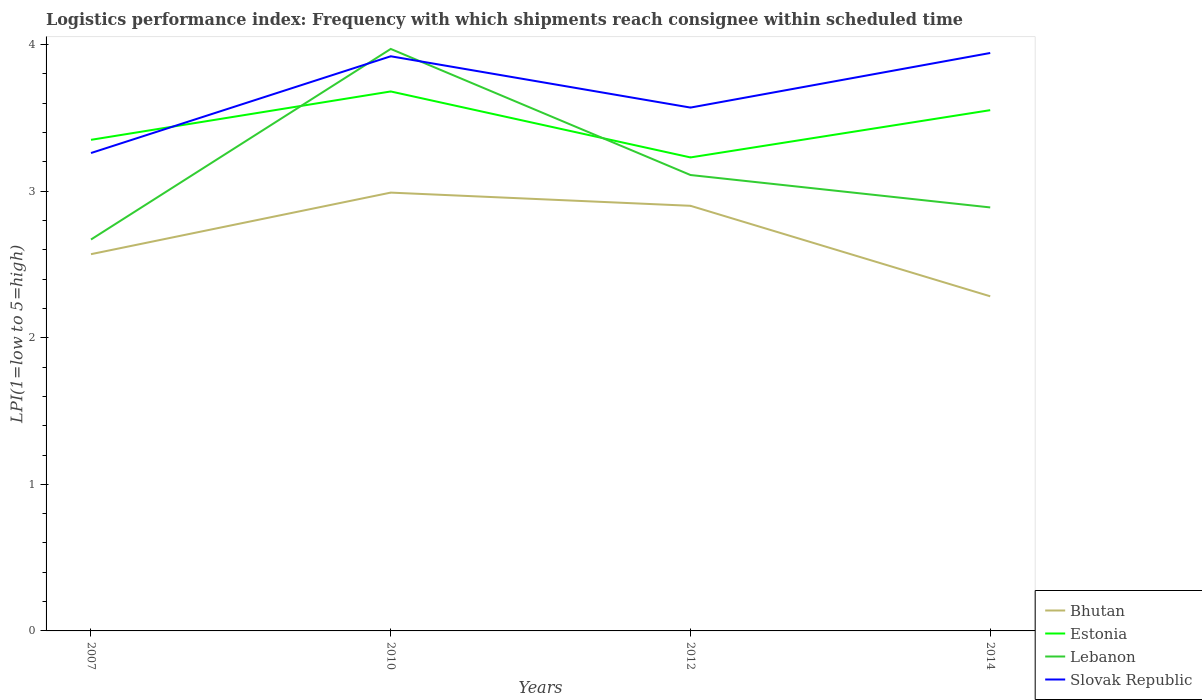Is the number of lines equal to the number of legend labels?
Your answer should be compact. Yes. Across all years, what is the maximum logistics performance index in Bhutan?
Offer a very short reply. 2.28. In which year was the logistics performance index in Bhutan maximum?
Your response must be concise. 2014. What is the total logistics performance index in Slovak Republic in the graph?
Keep it short and to the point. -0.66. What is the difference between the highest and the second highest logistics performance index in Lebanon?
Provide a succinct answer. 1.3. What is the difference between the highest and the lowest logistics performance index in Slovak Republic?
Provide a succinct answer. 2. Is the logistics performance index in Slovak Republic strictly greater than the logistics performance index in Estonia over the years?
Offer a terse response. No. What is the difference between two consecutive major ticks on the Y-axis?
Your response must be concise. 1. Does the graph contain any zero values?
Keep it short and to the point. No. Where does the legend appear in the graph?
Offer a terse response. Bottom right. How many legend labels are there?
Your response must be concise. 4. How are the legend labels stacked?
Provide a succinct answer. Vertical. What is the title of the graph?
Keep it short and to the point. Logistics performance index: Frequency with which shipments reach consignee within scheduled time. Does "Malawi" appear as one of the legend labels in the graph?
Your response must be concise. No. What is the label or title of the Y-axis?
Provide a succinct answer. LPI(1=low to 5=high). What is the LPI(1=low to 5=high) of Bhutan in 2007?
Give a very brief answer. 2.57. What is the LPI(1=low to 5=high) in Estonia in 2007?
Make the answer very short. 3.35. What is the LPI(1=low to 5=high) in Lebanon in 2007?
Provide a succinct answer. 2.67. What is the LPI(1=low to 5=high) in Slovak Republic in 2007?
Ensure brevity in your answer.  3.26. What is the LPI(1=low to 5=high) of Bhutan in 2010?
Ensure brevity in your answer.  2.99. What is the LPI(1=low to 5=high) in Estonia in 2010?
Your response must be concise. 3.68. What is the LPI(1=low to 5=high) of Lebanon in 2010?
Ensure brevity in your answer.  3.97. What is the LPI(1=low to 5=high) of Slovak Republic in 2010?
Ensure brevity in your answer.  3.92. What is the LPI(1=low to 5=high) of Bhutan in 2012?
Offer a very short reply. 2.9. What is the LPI(1=low to 5=high) in Estonia in 2012?
Give a very brief answer. 3.23. What is the LPI(1=low to 5=high) of Lebanon in 2012?
Ensure brevity in your answer.  3.11. What is the LPI(1=low to 5=high) of Slovak Republic in 2012?
Ensure brevity in your answer.  3.57. What is the LPI(1=low to 5=high) in Bhutan in 2014?
Provide a short and direct response. 2.28. What is the LPI(1=low to 5=high) in Estonia in 2014?
Offer a very short reply. 3.55. What is the LPI(1=low to 5=high) in Lebanon in 2014?
Make the answer very short. 2.89. What is the LPI(1=low to 5=high) in Slovak Republic in 2014?
Offer a very short reply. 3.94. Across all years, what is the maximum LPI(1=low to 5=high) in Bhutan?
Provide a short and direct response. 2.99. Across all years, what is the maximum LPI(1=low to 5=high) of Estonia?
Keep it short and to the point. 3.68. Across all years, what is the maximum LPI(1=low to 5=high) in Lebanon?
Your response must be concise. 3.97. Across all years, what is the maximum LPI(1=low to 5=high) in Slovak Republic?
Your answer should be very brief. 3.94. Across all years, what is the minimum LPI(1=low to 5=high) in Bhutan?
Your answer should be very brief. 2.28. Across all years, what is the minimum LPI(1=low to 5=high) of Estonia?
Provide a short and direct response. 3.23. Across all years, what is the minimum LPI(1=low to 5=high) in Lebanon?
Keep it short and to the point. 2.67. Across all years, what is the minimum LPI(1=low to 5=high) of Slovak Republic?
Give a very brief answer. 3.26. What is the total LPI(1=low to 5=high) in Bhutan in the graph?
Your answer should be compact. 10.74. What is the total LPI(1=low to 5=high) of Estonia in the graph?
Offer a terse response. 13.81. What is the total LPI(1=low to 5=high) in Lebanon in the graph?
Your answer should be compact. 12.64. What is the total LPI(1=low to 5=high) in Slovak Republic in the graph?
Your response must be concise. 14.69. What is the difference between the LPI(1=low to 5=high) in Bhutan in 2007 and that in 2010?
Give a very brief answer. -0.42. What is the difference between the LPI(1=low to 5=high) of Estonia in 2007 and that in 2010?
Ensure brevity in your answer.  -0.33. What is the difference between the LPI(1=low to 5=high) of Slovak Republic in 2007 and that in 2010?
Make the answer very short. -0.66. What is the difference between the LPI(1=low to 5=high) of Bhutan in 2007 and that in 2012?
Your answer should be very brief. -0.33. What is the difference between the LPI(1=low to 5=high) of Estonia in 2007 and that in 2012?
Offer a very short reply. 0.12. What is the difference between the LPI(1=low to 5=high) of Lebanon in 2007 and that in 2012?
Make the answer very short. -0.44. What is the difference between the LPI(1=low to 5=high) of Slovak Republic in 2007 and that in 2012?
Offer a very short reply. -0.31. What is the difference between the LPI(1=low to 5=high) in Bhutan in 2007 and that in 2014?
Make the answer very short. 0.29. What is the difference between the LPI(1=low to 5=high) in Estonia in 2007 and that in 2014?
Ensure brevity in your answer.  -0.2. What is the difference between the LPI(1=low to 5=high) of Lebanon in 2007 and that in 2014?
Offer a terse response. -0.22. What is the difference between the LPI(1=low to 5=high) in Slovak Republic in 2007 and that in 2014?
Offer a terse response. -0.68. What is the difference between the LPI(1=low to 5=high) of Bhutan in 2010 and that in 2012?
Give a very brief answer. 0.09. What is the difference between the LPI(1=low to 5=high) of Estonia in 2010 and that in 2012?
Your answer should be very brief. 0.45. What is the difference between the LPI(1=low to 5=high) in Lebanon in 2010 and that in 2012?
Provide a succinct answer. 0.86. What is the difference between the LPI(1=low to 5=high) of Slovak Republic in 2010 and that in 2012?
Offer a terse response. 0.35. What is the difference between the LPI(1=low to 5=high) in Bhutan in 2010 and that in 2014?
Provide a succinct answer. 0.71. What is the difference between the LPI(1=low to 5=high) of Estonia in 2010 and that in 2014?
Keep it short and to the point. 0.13. What is the difference between the LPI(1=low to 5=high) of Lebanon in 2010 and that in 2014?
Offer a very short reply. 1.08. What is the difference between the LPI(1=low to 5=high) of Slovak Republic in 2010 and that in 2014?
Make the answer very short. -0.02. What is the difference between the LPI(1=low to 5=high) in Bhutan in 2012 and that in 2014?
Offer a terse response. 0.62. What is the difference between the LPI(1=low to 5=high) in Estonia in 2012 and that in 2014?
Offer a very short reply. -0.32. What is the difference between the LPI(1=low to 5=high) in Lebanon in 2012 and that in 2014?
Keep it short and to the point. 0.22. What is the difference between the LPI(1=low to 5=high) in Slovak Republic in 2012 and that in 2014?
Your answer should be very brief. -0.37. What is the difference between the LPI(1=low to 5=high) in Bhutan in 2007 and the LPI(1=low to 5=high) in Estonia in 2010?
Make the answer very short. -1.11. What is the difference between the LPI(1=low to 5=high) in Bhutan in 2007 and the LPI(1=low to 5=high) in Slovak Republic in 2010?
Provide a succinct answer. -1.35. What is the difference between the LPI(1=low to 5=high) of Estonia in 2007 and the LPI(1=low to 5=high) of Lebanon in 2010?
Offer a very short reply. -0.62. What is the difference between the LPI(1=low to 5=high) of Estonia in 2007 and the LPI(1=low to 5=high) of Slovak Republic in 2010?
Your answer should be compact. -0.57. What is the difference between the LPI(1=low to 5=high) in Lebanon in 2007 and the LPI(1=low to 5=high) in Slovak Republic in 2010?
Offer a terse response. -1.25. What is the difference between the LPI(1=low to 5=high) of Bhutan in 2007 and the LPI(1=low to 5=high) of Estonia in 2012?
Provide a succinct answer. -0.66. What is the difference between the LPI(1=low to 5=high) of Bhutan in 2007 and the LPI(1=low to 5=high) of Lebanon in 2012?
Your answer should be very brief. -0.54. What is the difference between the LPI(1=low to 5=high) of Estonia in 2007 and the LPI(1=low to 5=high) of Lebanon in 2012?
Make the answer very short. 0.24. What is the difference between the LPI(1=low to 5=high) of Estonia in 2007 and the LPI(1=low to 5=high) of Slovak Republic in 2012?
Provide a succinct answer. -0.22. What is the difference between the LPI(1=low to 5=high) of Lebanon in 2007 and the LPI(1=low to 5=high) of Slovak Republic in 2012?
Offer a terse response. -0.9. What is the difference between the LPI(1=low to 5=high) of Bhutan in 2007 and the LPI(1=low to 5=high) of Estonia in 2014?
Provide a succinct answer. -0.98. What is the difference between the LPI(1=low to 5=high) of Bhutan in 2007 and the LPI(1=low to 5=high) of Lebanon in 2014?
Keep it short and to the point. -0.32. What is the difference between the LPI(1=low to 5=high) in Bhutan in 2007 and the LPI(1=low to 5=high) in Slovak Republic in 2014?
Offer a terse response. -1.37. What is the difference between the LPI(1=low to 5=high) in Estonia in 2007 and the LPI(1=low to 5=high) in Lebanon in 2014?
Offer a terse response. 0.46. What is the difference between the LPI(1=low to 5=high) in Estonia in 2007 and the LPI(1=low to 5=high) in Slovak Republic in 2014?
Your answer should be compact. -0.59. What is the difference between the LPI(1=low to 5=high) in Lebanon in 2007 and the LPI(1=low to 5=high) in Slovak Republic in 2014?
Provide a succinct answer. -1.27. What is the difference between the LPI(1=low to 5=high) in Bhutan in 2010 and the LPI(1=low to 5=high) in Estonia in 2012?
Your response must be concise. -0.24. What is the difference between the LPI(1=low to 5=high) of Bhutan in 2010 and the LPI(1=low to 5=high) of Lebanon in 2012?
Give a very brief answer. -0.12. What is the difference between the LPI(1=low to 5=high) in Bhutan in 2010 and the LPI(1=low to 5=high) in Slovak Republic in 2012?
Your answer should be very brief. -0.58. What is the difference between the LPI(1=low to 5=high) of Estonia in 2010 and the LPI(1=low to 5=high) of Lebanon in 2012?
Offer a terse response. 0.57. What is the difference between the LPI(1=low to 5=high) in Estonia in 2010 and the LPI(1=low to 5=high) in Slovak Republic in 2012?
Ensure brevity in your answer.  0.11. What is the difference between the LPI(1=low to 5=high) of Lebanon in 2010 and the LPI(1=low to 5=high) of Slovak Republic in 2012?
Offer a terse response. 0.4. What is the difference between the LPI(1=low to 5=high) of Bhutan in 2010 and the LPI(1=low to 5=high) of Estonia in 2014?
Provide a short and direct response. -0.56. What is the difference between the LPI(1=low to 5=high) in Bhutan in 2010 and the LPI(1=low to 5=high) in Lebanon in 2014?
Ensure brevity in your answer.  0.1. What is the difference between the LPI(1=low to 5=high) in Bhutan in 2010 and the LPI(1=low to 5=high) in Slovak Republic in 2014?
Make the answer very short. -0.95. What is the difference between the LPI(1=low to 5=high) of Estonia in 2010 and the LPI(1=low to 5=high) of Lebanon in 2014?
Make the answer very short. 0.79. What is the difference between the LPI(1=low to 5=high) of Estonia in 2010 and the LPI(1=low to 5=high) of Slovak Republic in 2014?
Provide a succinct answer. -0.26. What is the difference between the LPI(1=low to 5=high) in Lebanon in 2010 and the LPI(1=low to 5=high) in Slovak Republic in 2014?
Make the answer very short. 0.03. What is the difference between the LPI(1=low to 5=high) in Bhutan in 2012 and the LPI(1=low to 5=high) in Estonia in 2014?
Provide a succinct answer. -0.65. What is the difference between the LPI(1=low to 5=high) of Bhutan in 2012 and the LPI(1=low to 5=high) of Lebanon in 2014?
Keep it short and to the point. 0.01. What is the difference between the LPI(1=low to 5=high) of Bhutan in 2012 and the LPI(1=low to 5=high) of Slovak Republic in 2014?
Your answer should be compact. -1.04. What is the difference between the LPI(1=low to 5=high) in Estonia in 2012 and the LPI(1=low to 5=high) in Lebanon in 2014?
Your answer should be very brief. 0.34. What is the difference between the LPI(1=low to 5=high) in Estonia in 2012 and the LPI(1=low to 5=high) in Slovak Republic in 2014?
Give a very brief answer. -0.71. What is the difference between the LPI(1=low to 5=high) of Lebanon in 2012 and the LPI(1=low to 5=high) of Slovak Republic in 2014?
Give a very brief answer. -0.83. What is the average LPI(1=low to 5=high) in Bhutan per year?
Provide a short and direct response. 2.69. What is the average LPI(1=low to 5=high) in Estonia per year?
Keep it short and to the point. 3.45. What is the average LPI(1=low to 5=high) in Lebanon per year?
Your answer should be very brief. 3.16. What is the average LPI(1=low to 5=high) of Slovak Republic per year?
Your response must be concise. 3.67. In the year 2007, what is the difference between the LPI(1=low to 5=high) of Bhutan and LPI(1=low to 5=high) of Estonia?
Your answer should be compact. -0.78. In the year 2007, what is the difference between the LPI(1=low to 5=high) of Bhutan and LPI(1=low to 5=high) of Slovak Republic?
Your answer should be very brief. -0.69. In the year 2007, what is the difference between the LPI(1=low to 5=high) in Estonia and LPI(1=low to 5=high) in Lebanon?
Keep it short and to the point. 0.68. In the year 2007, what is the difference between the LPI(1=low to 5=high) in Estonia and LPI(1=low to 5=high) in Slovak Republic?
Ensure brevity in your answer.  0.09. In the year 2007, what is the difference between the LPI(1=low to 5=high) of Lebanon and LPI(1=low to 5=high) of Slovak Republic?
Your response must be concise. -0.59. In the year 2010, what is the difference between the LPI(1=low to 5=high) of Bhutan and LPI(1=low to 5=high) of Estonia?
Your answer should be compact. -0.69. In the year 2010, what is the difference between the LPI(1=low to 5=high) of Bhutan and LPI(1=low to 5=high) of Lebanon?
Your response must be concise. -0.98. In the year 2010, what is the difference between the LPI(1=low to 5=high) of Bhutan and LPI(1=low to 5=high) of Slovak Republic?
Make the answer very short. -0.93. In the year 2010, what is the difference between the LPI(1=low to 5=high) in Estonia and LPI(1=low to 5=high) in Lebanon?
Keep it short and to the point. -0.29. In the year 2010, what is the difference between the LPI(1=low to 5=high) in Estonia and LPI(1=low to 5=high) in Slovak Republic?
Keep it short and to the point. -0.24. In the year 2010, what is the difference between the LPI(1=low to 5=high) of Lebanon and LPI(1=low to 5=high) of Slovak Republic?
Make the answer very short. 0.05. In the year 2012, what is the difference between the LPI(1=low to 5=high) in Bhutan and LPI(1=low to 5=high) in Estonia?
Provide a succinct answer. -0.33. In the year 2012, what is the difference between the LPI(1=low to 5=high) of Bhutan and LPI(1=low to 5=high) of Lebanon?
Your answer should be very brief. -0.21. In the year 2012, what is the difference between the LPI(1=low to 5=high) in Bhutan and LPI(1=low to 5=high) in Slovak Republic?
Provide a succinct answer. -0.67. In the year 2012, what is the difference between the LPI(1=low to 5=high) of Estonia and LPI(1=low to 5=high) of Lebanon?
Your response must be concise. 0.12. In the year 2012, what is the difference between the LPI(1=low to 5=high) in Estonia and LPI(1=low to 5=high) in Slovak Republic?
Your answer should be compact. -0.34. In the year 2012, what is the difference between the LPI(1=low to 5=high) of Lebanon and LPI(1=low to 5=high) of Slovak Republic?
Make the answer very short. -0.46. In the year 2014, what is the difference between the LPI(1=low to 5=high) in Bhutan and LPI(1=low to 5=high) in Estonia?
Your answer should be compact. -1.27. In the year 2014, what is the difference between the LPI(1=low to 5=high) in Bhutan and LPI(1=low to 5=high) in Lebanon?
Your answer should be compact. -0.61. In the year 2014, what is the difference between the LPI(1=low to 5=high) of Bhutan and LPI(1=low to 5=high) of Slovak Republic?
Offer a very short reply. -1.66. In the year 2014, what is the difference between the LPI(1=low to 5=high) of Estonia and LPI(1=low to 5=high) of Lebanon?
Provide a succinct answer. 0.66. In the year 2014, what is the difference between the LPI(1=low to 5=high) in Estonia and LPI(1=low to 5=high) in Slovak Republic?
Your response must be concise. -0.39. In the year 2014, what is the difference between the LPI(1=low to 5=high) in Lebanon and LPI(1=low to 5=high) in Slovak Republic?
Ensure brevity in your answer.  -1.05. What is the ratio of the LPI(1=low to 5=high) in Bhutan in 2007 to that in 2010?
Ensure brevity in your answer.  0.86. What is the ratio of the LPI(1=low to 5=high) in Estonia in 2007 to that in 2010?
Make the answer very short. 0.91. What is the ratio of the LPI(1=low to 5=high) of Lebanon in 2007 to that in 2010?
Your answer should be very brief. 0.67. What is the ratio of the LPI(1=low to 5=high) of Slovak Republic in 2007 to that in 2010?
Offer a very short reply. 0.83. What is the ratio of the LPI(1=low to 5=high) of Bhutan in 2007 to that in 2012?
Provide a short and direct response. 0.89. What is the ratio of the LPI(1=low to 5=high) of Estonia in 2007 to that in 2012?
Offer a terse response. 1.04. What is the ratio of the LPI(1=low to 5=high) in Lebanon in 2007 to that in 2012?
Offer a very short reply. 0.86. What is the ratio of the LPI(1=low to 5=high) in Slovak Republic in 2007 to that in 2012?
Make the answer very short. 0.91. What is the ratio of the LPI(1=low to 5=high) of Bhutan in 2007 to that in 2014?
Offer a terse response. 1.13. What is the ratio of the LPI(1=low to 5=high) in Estonia in 2007 to that in 2014?
Provide a short and direct response. 0.94. What is the ratio of the LPI(1=low to 5=high) of Lebanon in 2007 to that in 2014?
Offer a very short reply. 0.92. What is the ratio of the LPI(1=low to 5=high) of Slovak Republic in 2007 to that in 2014?
Ensure brevity in your answer.  0.83. What is the ratio of the LPI(1=low to 5=high) in Bhutan in 2010 to that in 2012?
Ensure brevity in your answer.  1.03. What is the ratio of the LPI(1=low to 5=high) of Estonia in 2010 to that in 2012?
Keep it short and to the point. 1.14. What is the ratio of the LPI(1=low to 5=high) in Lebanon in 2010 to that in 2012?
Ensure brevity in your answer.  1.28. What is the ratio of the LPI(1=low to 5=high) in Slovak Republic in 2010 to that in 2012?
Provide a short and direct response. 1.1. What is the ratio of the LPI(1=low to 5=high) in Bhutan in 2010 to that in 2014?
Keep it short and to the point. 1.31. What is the ratio of the LPI(1=low to 5=high) in Estonia in 2010 to that in 2014?
Offer a terse response. 1.04. What is the ratio of the LPI(1=low to 5=high) of Lebanon in 2010 to that in 2014?
Your answer should be compact. 1.37. What is the ratio of the LPI(1=low to 5=high) of Slovak Republic in 2010 to that in 2014?
Ensure brevity in your answer.  0.99. What is the ratio of the LPI(1=low to 5=high) in Bhutan in 2012 to that in 2014?
Make the answer very short. 1.27. What is the ratio of the LPI(1=low to 5=high) in Estonia in 2012 to that in 2014?
Offer a terse response. 0.91. What is the ratio of the LPI(1=low to 5=high) of Lebanon in 2012 to that in 2014?
Your response must be concise. 1.08. What is the ratio of the LPI(1=low to 5=high) of Slovak Republic in 2012 to that in 2014?
Your answer should be compact. 0.91. What is the difference between the highest and the second highest LPI(1=low to 5=high) of Bhutan?
Keep it short and to the point. 0.09. What is the difference between the highest and the second highest LPI(1=low to 5=high) of Estonia?
Provide a short and direct response. 0.13. What is the difference between the highest and the second highest LPI(1=low to 5=high) in Lebanon?
Offer a terse response. 0.86. What is the difference between the highest and the second highest LPI(1=low to 5=high) in Slovak Republic?
Your answer should be very brief. 0.02. What is the difference between the highest and the lowest LPI(1=low to 5=high) in Bhutan?
Provide a short and direct response. 0.71. What is the difference between the highest and the lowest LPI(1=low to 5=high) in Estonia?
Make the answer very short. 0.45. What is the difference between the highest and the lowest LPI(1=low to 5=high) of Slovak Republic?
Offer a terse response. 0.68. 